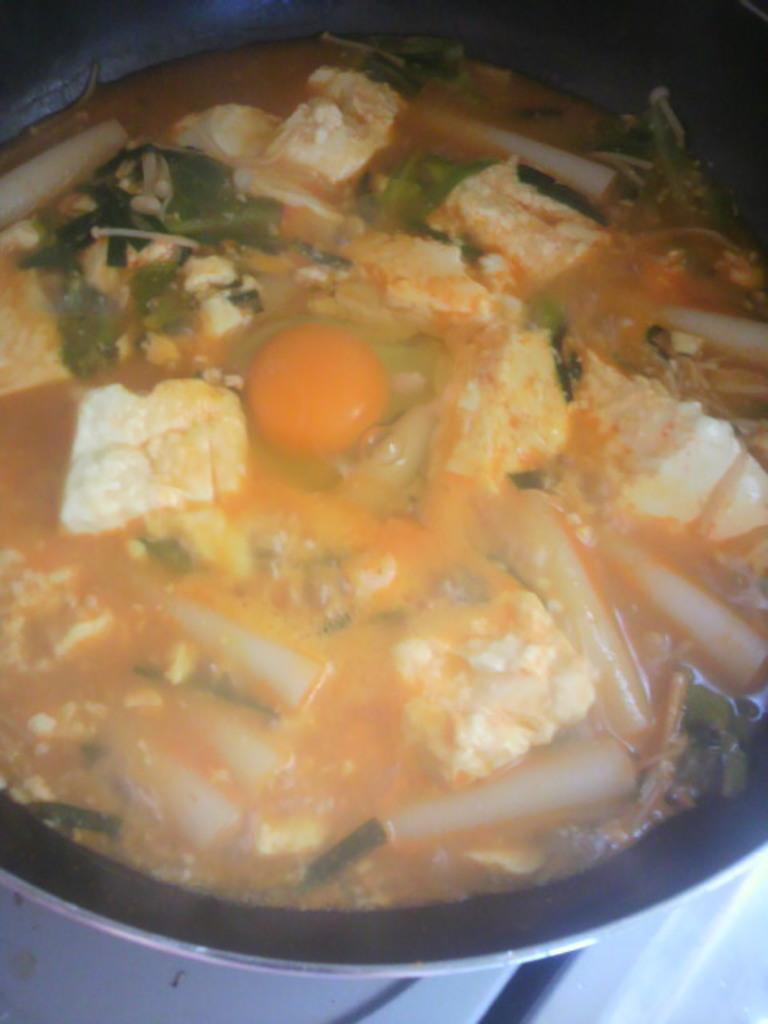What can be seen in the image related to food? There is a group of food items in the image. Can you describe the egg in the image? There is an egg placed in a bowl in the image. Who is the expert in the image providing advice on digestion? There is no expert or advice on digestion present in the image. 